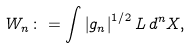<formula> <loc_0><loc_0><loc_500><loc_500>W _ { n } \colon = \int \left | g _ { n } \right | ^ { 1 / 2 } L \, d ^ { n } X ,</formula> 